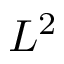<formula> <loc_0><loc_0><loc_500><loc_500>L ^ { 2 }</formula> 